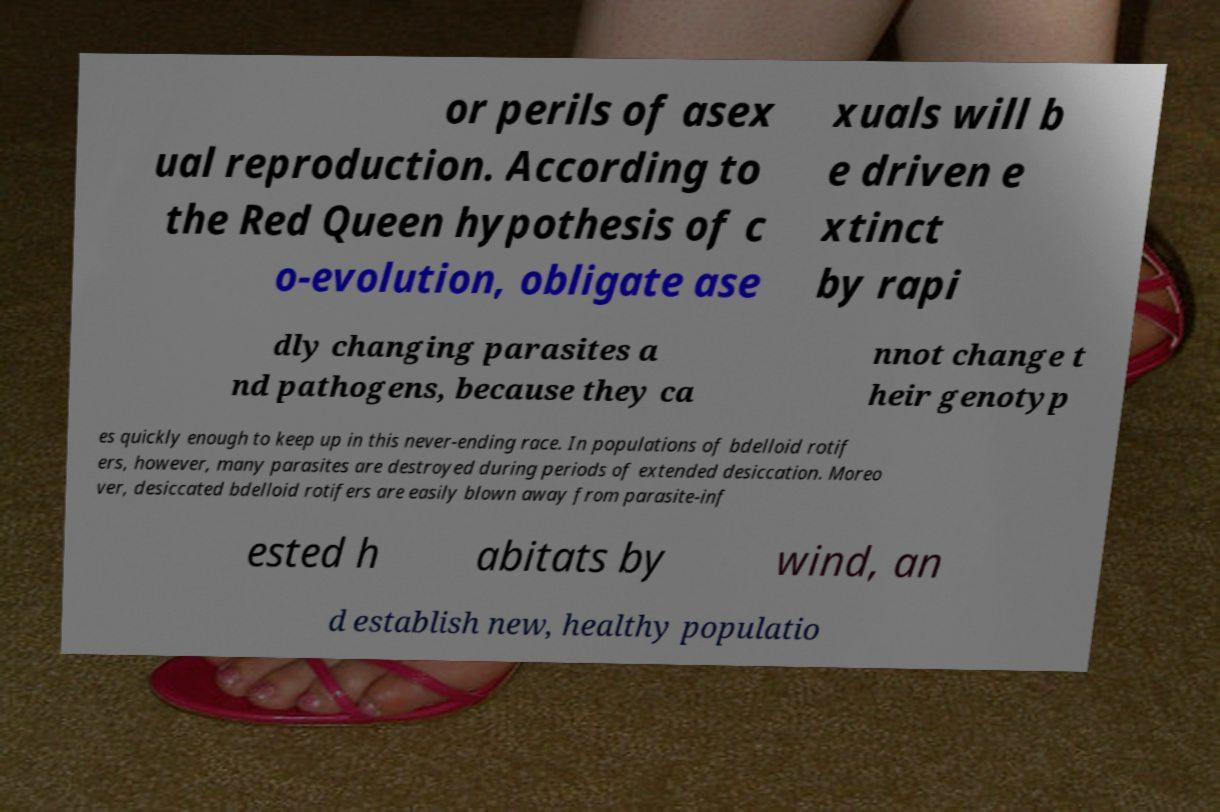Can you read and provide the text displayed in the image?This photo seems to have some interesting text. Can you extract and type it out for me? or perils of asex ual reproduction. According to the Red Queen hypothesis of c o-evolution, obligate ase xuals will b e driven e xtinct by rapi dly changing parasites a nd pathogens, because they ca nnot change t heir genotyp es quickly enough to keep up in this never-ending race. In populations of bdelloid rotif ers, however, many parasites are destroyed during periods of extended desiccation. Moreo ver, desiccated bdelloid rotifers are easily blown away from parasite-inf ested h abitats by wind, an d establish new, healthy populatio 